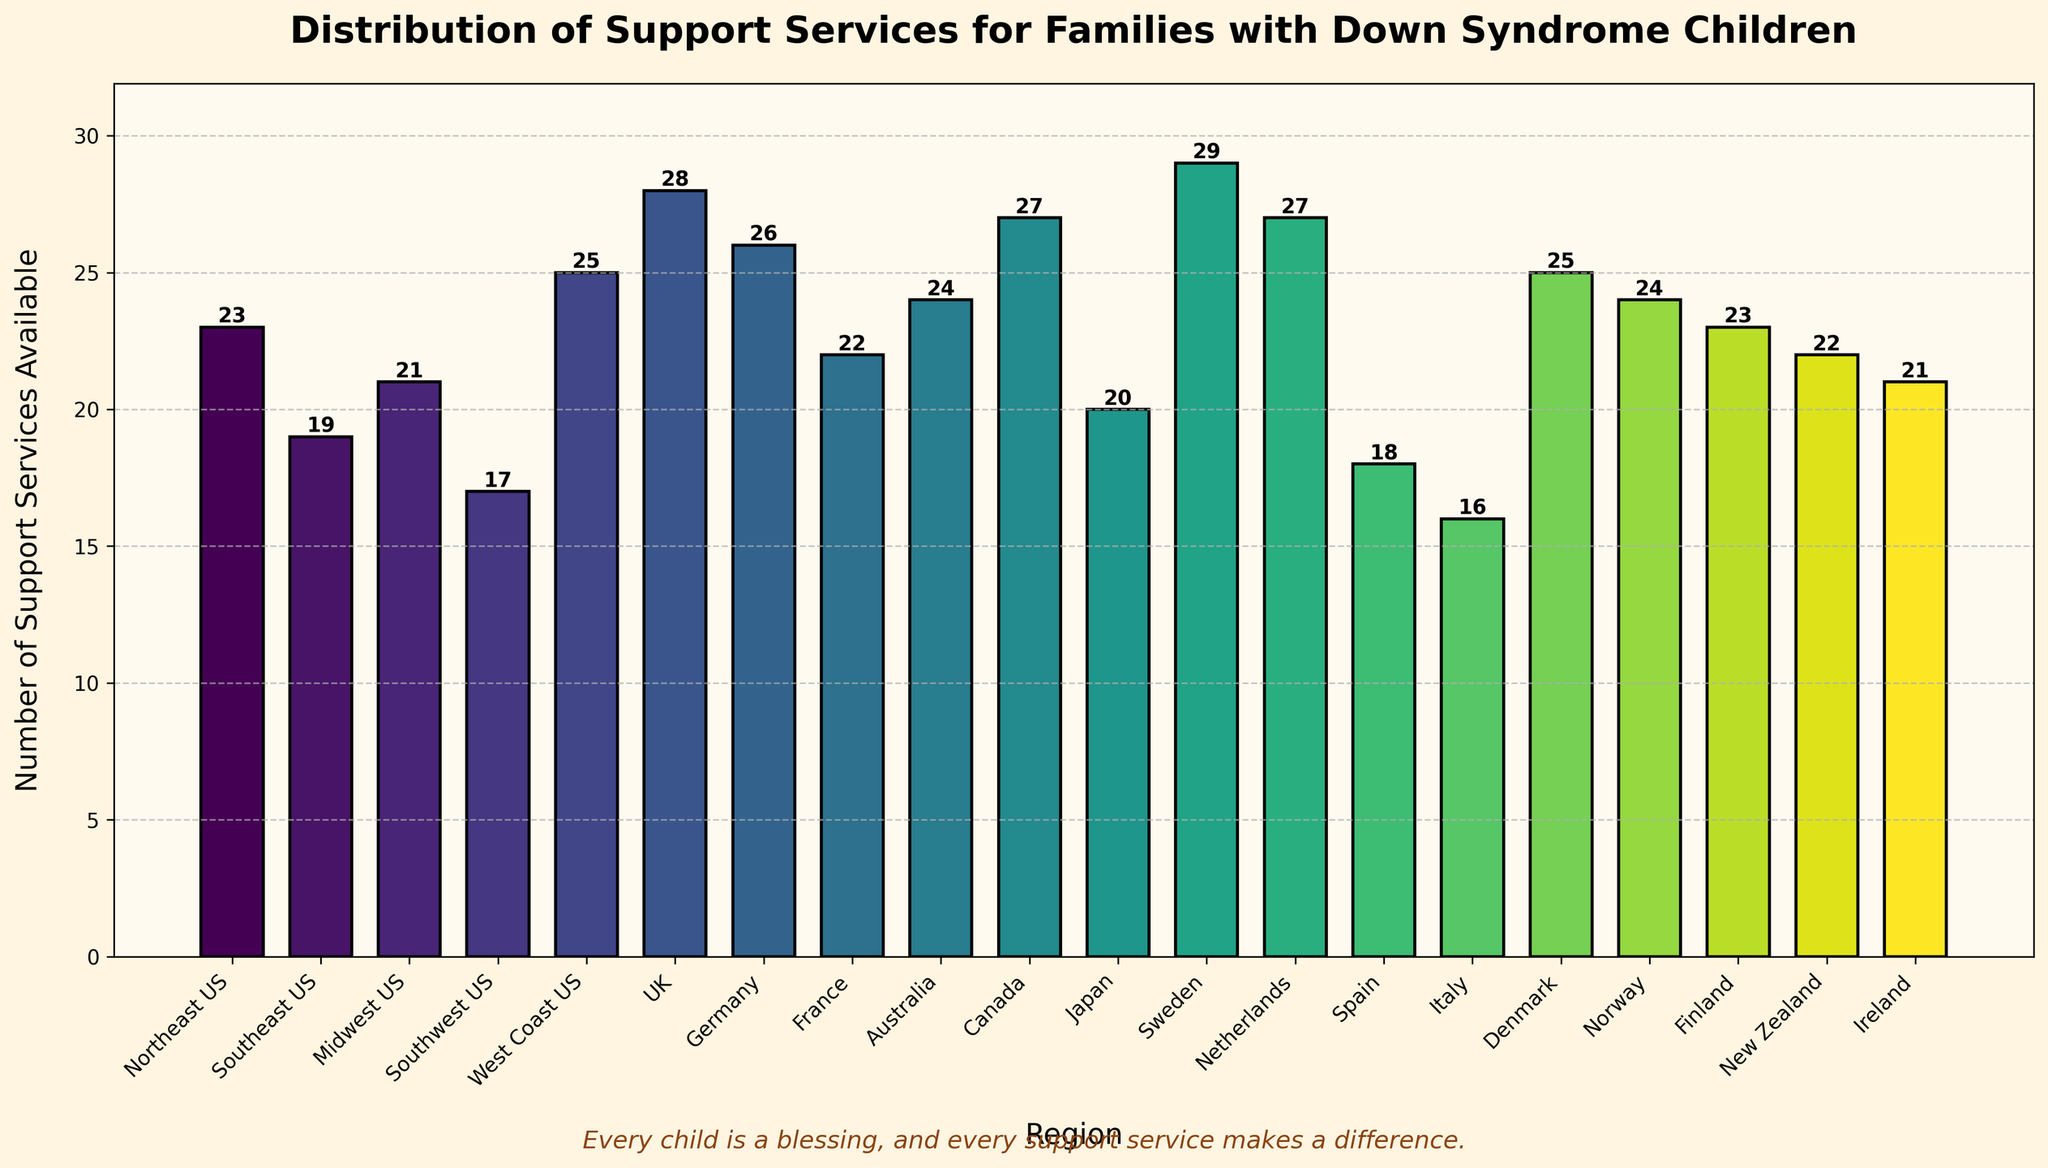What's the region with the highest number of support services available? To find the region with the highest number of support services, we look for the tallest bar in the chart. Sweden has the tallest bar.
Answer: Sweden Which regions have more than 25 support services available? To identify these regions, check for bars with heights above 25 units. These include UK, Germany, Canada, and Netherlands
Answer: UK, Germany, Canada, Netherlands What's the difference in the number of support services between the Northeast US and Southeast US? The Northeast US has 23 services while the Southeast US has 19. Subtract 19 from 23: 23 - 19 = 4
Answer: 4 How many regions have a number of support services within the range of 20 to 25, inclusive? Count the bars that are between 20 and 25 units tall (including both limits). These regions are: Northeast US, Midwest US, Japan, France, New Zealand, Ireland, Denmark, Norway, and Australia. Total count is 9.
Answer: 9 What's the total number of support services available in the UK and Germany combined? The UK has 28 services and Germany has 26. Adding them together: 28 + 26 = 54
Answer: 54 Which region has the least number of support services available, and how many does it have? To determine this, look for the shortest bar in the chart. Italy has the shortest bar with 16 support services.
Answer: Italy, 16 Are there any regions with an equal number of support services? If so, which are they and how many services do they each have? Scan for pairs of bars with the same height. Canada and Netherlands both have 27 services. Australia and Norway both have 24 services. Finland and Northeast US both have 23 services. France and New Zealand both have 22 services. Southeast US and Japan both have 20 services.
Answer: Canada & Netherlands (27), Australia & Norway (24), Finland & Northeast US (23), France & New Zealand (22), Southeast US & Japan (20) What is the average number of support services available across all regions? Sum all the values and divide by the number of regions. Calculations: (23 + 19 + 21 + 17 + 25 + 28 + 26 + 22 + 24 + 27 + 20 + 29 + 27 + 18 + 16 + 25 + 24 + 23 + 22 + 21) / 20 = 430 / 20 = 21.5
Answer: 21.5 Which regions have fewer support services available than Japan? Japan has 20 services. Look for bars shorter than this. These regions are Southeast US, Southwest US, Spain, and Italy.
Answer: Southeast US, Southwest US, Spain, Italy What is the combined number of support services available for all the European regions listed? Sum the number of services for the European regions: UK (28), Germany (26), France (22), Sweden (29), Netherlands (27), Spain (18), Italy (16), Denmark (25), Norway (24), Finland (23), Ireland (21). Sum = 28 + 26 + 22 + 29 + 27 + 18 + 16 + 25 + 24 + 23 + 21 = 259
Answer: 259 